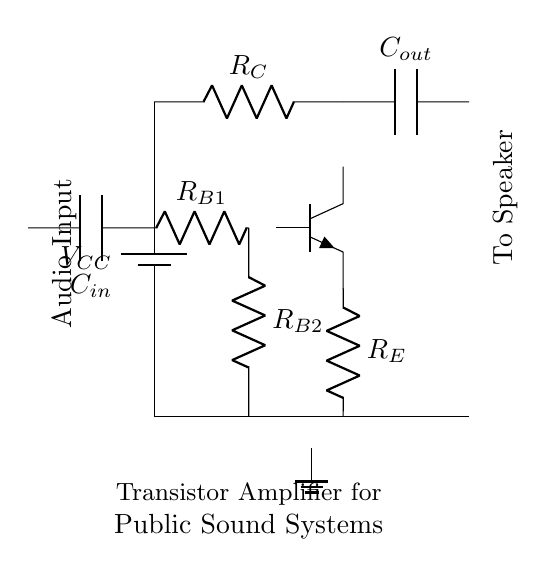What type of transistor is used in this circuit? The diagram shows an NPN transistor, identified by the symbol used in the circuit. The three terminals labeled are the collector, emitter, and base.
Answer: NPN What does the resistor labeled R_C do? R_C is the collector resistor, which helps to limit the current flowing through the collector of the transistor to prevent damage and affects the voltage gain of the amplifier.
Answer: Limits current What is the function of the capacitor labeled C_in? C_in is an input coupling capacitor that blocks any DC voltage from the audio input while allowing AC signals (the audio) to pass through to the base of the transistor.
Answer: Blocks DC How many resistors are used in the base circuit? There are two resistors, R_B1 and R_B2, connected in a voltage divider configuration to set the biasing point of the transistor.
Answer: Two What is the voltage supply for this amplifier circuit? The voltage supply, labeled V_CC, provides the necessary voltage for the operation of the transistor and is essential for the amplifier's functionality, usually indicated in the design.
Answer: V_CC What is the purpose of resistor R_E in this circuit? R_E is the emitter resistor, which provides stability and improves linearity by setting the correct operating point of the transistor and helps to stabilize the gain against variations in temperature and transistor characteristics.
Answer: Stability 